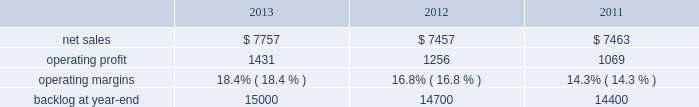Warfighter information network-tactical ( win-t ) ; command , control , battle management and communications ( c2bmc ) ; and twic ) .
Partially offsetting the decreases were higher net sales of approximately $ 140 million from qtc , which was acquired early in the fourth quarter of 2011 ; and about $ 65 million from increased activity on numerous other programs , primarily federal cyber security programs and ptds operational support .
Is&gs 2019 operating profit for 2012 decreased $ 66 million , or 8% ( 8 % ) , compared to 2011 .
The decrease was attributable to lower operating profit of approximately $ 50 million due to the favorable impact of the odin contract completion in 2011 ; about $ 25 million due to an increase in reserves for performance issues related to an international airborne surveillance system in 2012 ; and approximately $ 20 million due to lower volume on certain programs ( primarily c2bmc and win-t ) .
Partially offsetting the decreases was an increase in operating profit due to higher risk retirements of approximately $ 15 million from the twic program ; and about $ 10 million due to increased activity on numerous other programs , primarily federal cyber security programs and ptds operational support .
Operating profit for the jtrs program was comparable as a decrease in volume was offset by a decrease in reserves .
Adjustments not related to volume , including net profit booking rate adjustments and other matters described above , were approximately $ 20 million higher for 2012 compared to 2011 .
Backlog backlog decreased in 2013 compared to 2012 primarily due to lower orders on several programs ( such as eram and ngi ) , higher sales on certain programs ( the national science foundation antarctic support and the disa gsm-o ) , and declining activities on several smaller programs primarily due to the continued downturn in federal information technology budgets .
Backlog decreased in 2012 compared to 2011 primarily due to the substantial completion of various programs in 2011 ( primarily odin , u.k .
Census , and jtrs ) .
Trends we expect is&gs 2019 net sales to decline in 2014 in the high single digit percentage range as compared to 2013 primarily due to the continued downturn in federal information technology budgets .
Operating profit is also expected to decline in 2014 in the high single digit percentage range consistent with the expected decline in net sales , resulting in margins that are comparable with 2013 results .
Missiles and fire control our mfc business segment provides air and missile defense systems ; tactical missiles and air-to-ground precision strike weapon systems ; logistics and other technical services ; fire control systems ; mission operations support , readiness , engineering support , and integration services ; and manned and unmanned ground vehicles .
Mfc 2019s major programs include pac-3 , thaad , multiple launch rocket system , hellfire , joint air-to-surface standoff missile ( jassm ) , javelin , apache fire control system ( apache ) , sniper ae , low altitude navigation and targeting infrared for night ( lantirn ae ) , and sof clss .
Mfc 2019s operating results included the following ( in millions ) : .
2013 compared to 2012 mfc 2019s net sales for 2013 increased $ 300 million , or 4% ( 4 % ) , compared to 2012 .
The increase was primarily attributable to higher net sales of approximately $ 450 million for air and missile defense programs ( thaad and pac-3 ) due to increased production volume and deliveries ; about $ 70 million for fire control programs due to net increased deliveries and volume ; and approximately $ 55 million for tactical missile programs due to net increased deliveries .
The increases were partially offset by lower net sales of about $ 275 million for various technical services programs due to lower volume driven by the continuing impact of defense budget reductions and related competitive pressures .
The increase for fire control programs was primarily attributable to increased deliveries on the sniper ae and lantirn ae programs , increased volume on the sof clss program , partially offset by lower volume on longbow fire control radar and other programs .
The increase for tactical missile programs was primarily attributable to increased deliveries on jassm and other programs , partially offset by fewer deliveries on the guided multiple launch rocket system and javelin programs. .
As part of the overall decline in the nets ales in 2013 what was the total decline in sales before the partial offsetting increase leading to the net decline in millions? 
Computations: ((50 + 25) + 20)
Answer: 95.0. 